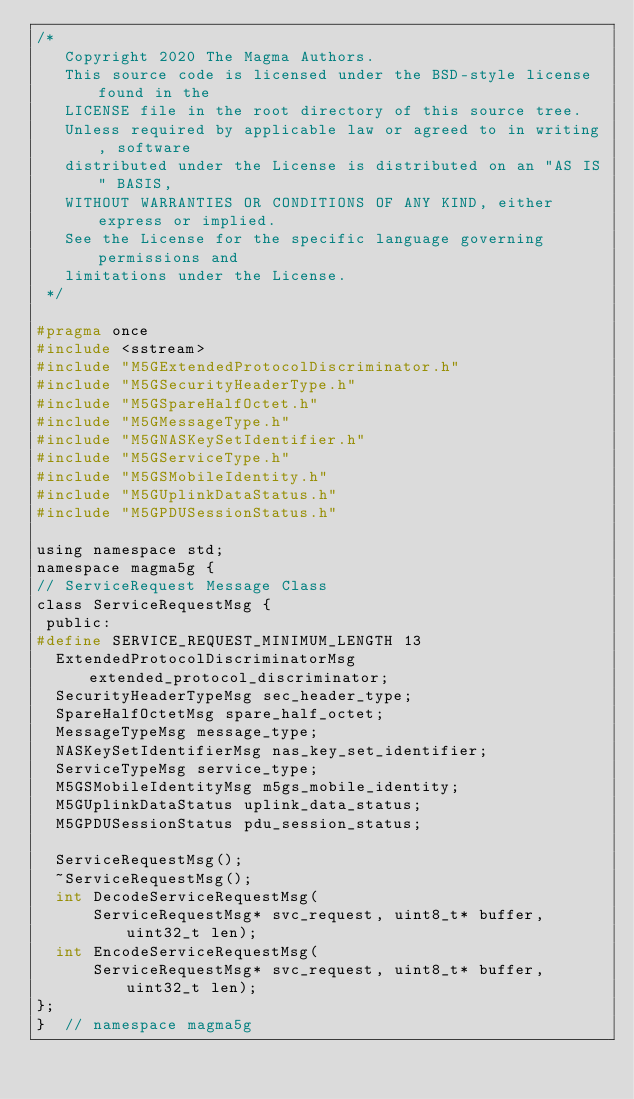Convert code to text. <code><loc_0><loc_0><loc_500><loc_500><_C_>/*
   Copyright 2020 The Magma Authors.
   This source code is licensed under the BSD-style license found in the
   LICENSE file in the root directory of this source tree.
   Unless required by applicable law or agreed to in writing, software
   distributed under the License is distributed on an "AS IS" BASIS,
   WITHOUT WARRANTIES OR CONDITIONS OF ANY KIND, either express or implied.
   See the License for the specific language governing permissions and
   limitations under the License.
 */

#pragma once
#include <sstream>
#include "M5GExtendedProtocolDiscriminator.h"
#include "M5GSecurityHeaderType.h"
#include "M5GSpareHalfOctet.h"
#include "M5GMessageType.h"
#include "M5GNASKeySetIdentifier.h"
#include "M5GServiceType.h"
#include "M5GSMobileIdentity.h"
#include "M5GUplinkDataStatus.h"
#include "M5GPDUSessionStatus.h"

using namespace std;
namespace magma5g {
// ServiceRequest Message Class
class ServiceRequestMsg {
 public:
#define SERVICE_REQUEST_MINIMUM_LENGTH 13
  ExtendedProtocolDiscriminatorMsg extended_protocol_discriminator;
  SecurityHeaderTypeMsg sec_header_type;
  SpareHalfOctetMsg spare_half_octet;
  MessageTypeMsg message_type;
  NASKeySetIdentifierMsg nas_key_set_identifier;
  ServiceTypeMsg service_type;
  M5GSMobileIdentityMsg m5gs_mobile_identity;
  M5GUplinkDataStatus uplink_data_status;
  M5GPDUSessionStatus pdu_session_status;

  ServiceRequestMsg();
  ~ServiceRequestMsg();
  int DecodeServiceRequestMsg(
      ServiceRequestMsg* svc_request, uint8_t* buffer, uint32_t len);
  int EncodeServiceRequestMsg(
      ServiceRequestMsg* svc_request, uint8_t* buffer, uint32_t len);
};
}  // namespace magma5g
</code> 